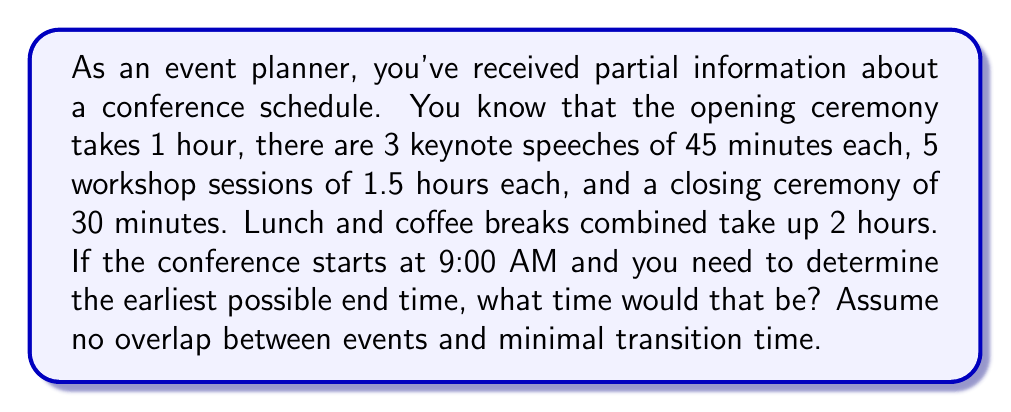What is the answer to this math problem? Let's break this down step-by-step:

1) First, let's calculate the total duration of all known events:
   
   Opening ceremony: $1 \text{ hour} = 60 \text{ minutes}$
   Keynote speeches: $3 \times 45 \text{ minutes} = 135 \text{ minutes}$
   Workshop sessions: $5 \times 1.5 \text{ hours} = 7.5 \text{ hours} = 450 \text{ minutes}$
   Closing ceremony: $30 \text{ minutes}$
   Lunch and coffee breaks: $2 \text{ hours} = 120 \text{ minutes}$

2) Now, let's sum up all these durations:
   
   $\text{Total time} = 60 + 135 + 450 + 30 + 120 = 795 \text{ minutes}$

3) Convert this to hours and minutes:
   
   $795 \text{ minutes} = 13 \text{ hours and } 15 \text{ minutes}$

4) The conference starts at 9:00 AM, so we add 13 hours and 15 minutes to this:
   
   $9:00 \text{ AM} + 13 \text{ hours} = 10:00 \text{ PM}$
   $10:00 \text{ PM} + 15 \text{ minutes} = 10:15 \text{ PM}$

Therefore, the earliest possible end time for the conference would be 10:15 PM.
Answer: 10:15 PM 